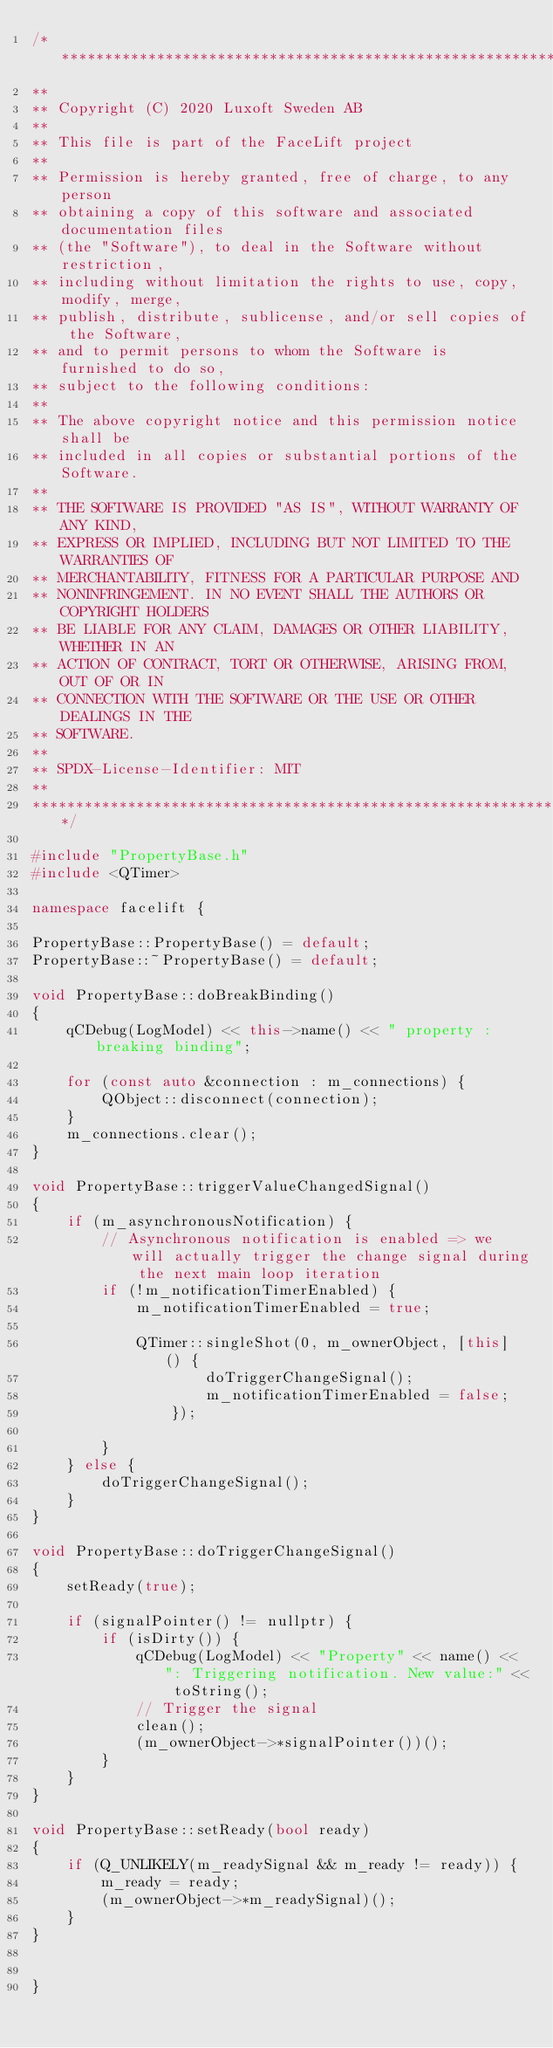<code> <loc_0><loc_0><loc_500><loc_500><_C++_>/**********************************************************************
**
** Copyright (C) 2020 Luxoft Sweden AB
**
** This file is part of the FaceLift project
**
** Permission is hereby granted, free of charge, to any person
** obtaining a copy of this software and associated documentation files
** (the "Software"), to deal in the Software without restriction,
** including without limitation the rights to use, copy, modify, merge,
** publish, distribute, sublicense, and/or sell copies of the Software,
** and to permit persons to whom the Software is furnished to do so,
** subject to the following conditions:
**
** The above copyright notice and this permission notice shall be
** included in all copies or substantial portions of the Software.
**
** THE SOFTWARE IS PROVIDED "AS IS", WITHOUT WARRANTY OF ANY KIND,
** EXPRESS OR IMPLIED, INCLUDING BUT NOT LIMITED TO THE WARRANTIES OF
** MERCHANTABILITY, FITNESS FOR A PARTICULAR PURPOSE AND
** NONINFRINGEMENT. IN NO EVENT SHALL THE AUTHORS OR COPYRIGHT HOLDERS
** BE LIABLE FOR ANY CLAIM, DAMAGES OR OTHER LIABILITY, WHETHER IN AN
** ACTION OF CONTRACT, TORT OR OTHERWISE, ARISING FROM, OUT OF OR IN
** CONNECTION WITH THE SOFTWARE OR THE USE OR OTHER DEALINGS IN THE
** SOFTWARE.
**
** SPDX-License-Identifier: MIT
**
**********************************************************************/

#include "PropertyBase.h"
#include <QTimer>

namespace facelift {

PropertyBase::PropertyBase() = default;
PropertyBase::~PropertyBase() = default;

void PropertyBase::doBreakBinding()
{
    qCDebug(LogModel) << this->name() << " property : breaking binding";

    for (const auto &connection : m_connections) {
        QObject::disconnect(connection);
    }
    m_connections.clear();
}

void PropertyBase::triggerValueChangedSignal()
{
    if (m_asynchronousNotification) {
        // Asynchronous notification is enabled => we will actually trigger the change signal during the next main loop iteration
        if (!m_notificationTimerEnabled) {
            m_notificationTimerEnabled = true;

            QTimer::singleShot(0, m_ownerObject, [this] () {
                    doTriggerChangeSignal();
                    m_notificationTimerEnabled = false;
                });

        }
    } else {
        doTriggerChangeSignal();
    }
}

void PropertyBase::doTriggerChangeSignal()
{
    setReady(true);

    if (signalPointer() != nullptr) {
        if (isDirty()) {
            qCDebug(LogModel) << "Property" << name() << ": Triggering notification. New value:" << toString();
            // Trigger the signal
            clean();
            (m_ownerObject->*signalPointer())();
        }
    }
}

void PropertyBase::setReady(bool ready)
{
    if (Q_UNLIKELY(m_readySignal && m_ready != ready)) {
        m_ready = ready;
        (m_ownerObject->*m_readySignal)();
    }
}


}
</code> 